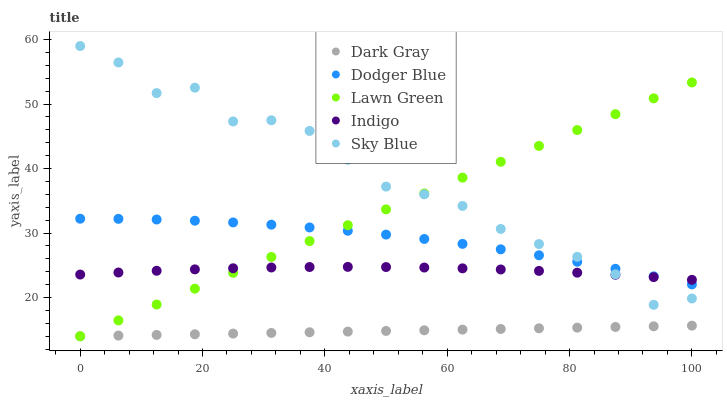Does Dark Gray have the minimum area under the curve?
Answer yes or no. Yes. Does Sky Blue have the maximum area under the curve?
Answer yes or no. Yes. Does Lawn Green have the minimum area under the curve?
Answer yes or no. No. Does Lawn Green have the maximum area under the curve?
Answer yes or no. No. Is Dark Gray the smoothest?
Answer yes or no. Yes. Is Sky Blue the roughest?
Answer yes or no. Yes. Is Lawn Green the smoothest?
Answer yes or no. No. Is Lawn Green the roughest?
Answer yes or no. No. Does Dark Gray have the lowest value?
Answer yes or no. Yes. Does Dodger Blue have the lowest value?
Answer yes or no. No. Does Sky Blue have the highest value?
Answer yes or no. Yes. Does Lawn Green have the highest value?
Answer yes or no. No. Is Dark Gray less than Sky Blue?
Answer yes or no. Yes. Is Indigo greater than Dark Gray?
Answer yes or no. Yes. Does Dodger Blue intersect Lawn Green?
Answer yes or no. Yes. Is Dodger Blue less than Lawn Green?
Answer yes or no. No. Is Dodger Blue greater than Lawn Green?
Answer yes or no. No. Does Dark Gray intersect Sky Blue?
Answer yes or no. No. 